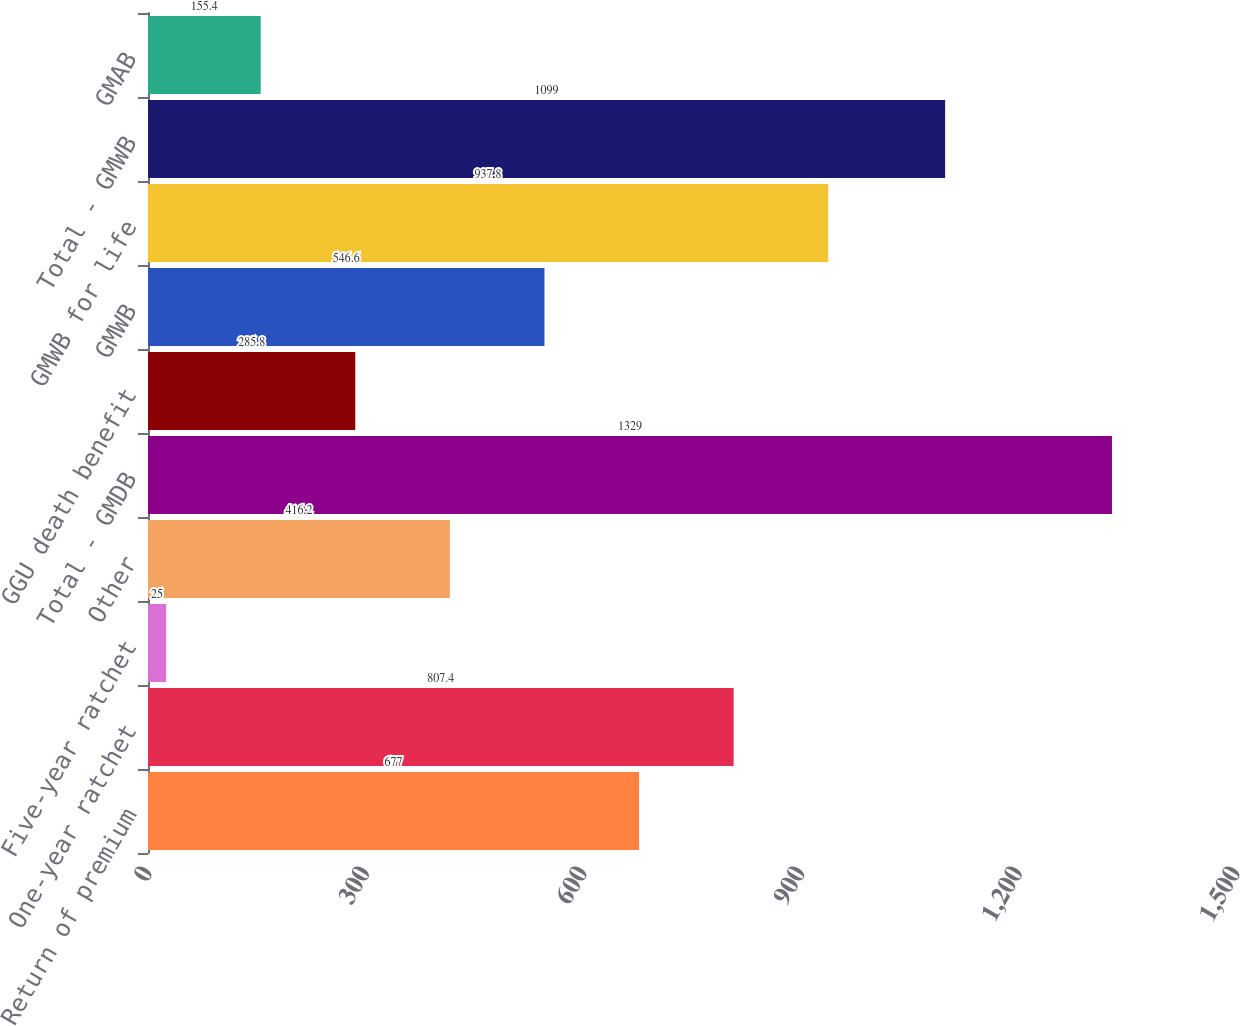<chart> <loc_0><loc_0><loc_500><loc_500><bar_chart><fcel>Return of premium<fcel>One-year ratchet<fcel>Five-year ratchet<fcel>Other<fcel>Total - GMDB<fcel>GGU death benefit<fcel>GMWB<fcel>GMWB for life<fcel>Total - GMWB<fcel>GMAB<nl><fcel>677<fcel>807.4<fcel>25<fcel>416.2<fcel>1329<fcel>285.8<fcel>546.6<fcel>937.8<fcel>1099<fcel>155.4<nl></chart> 